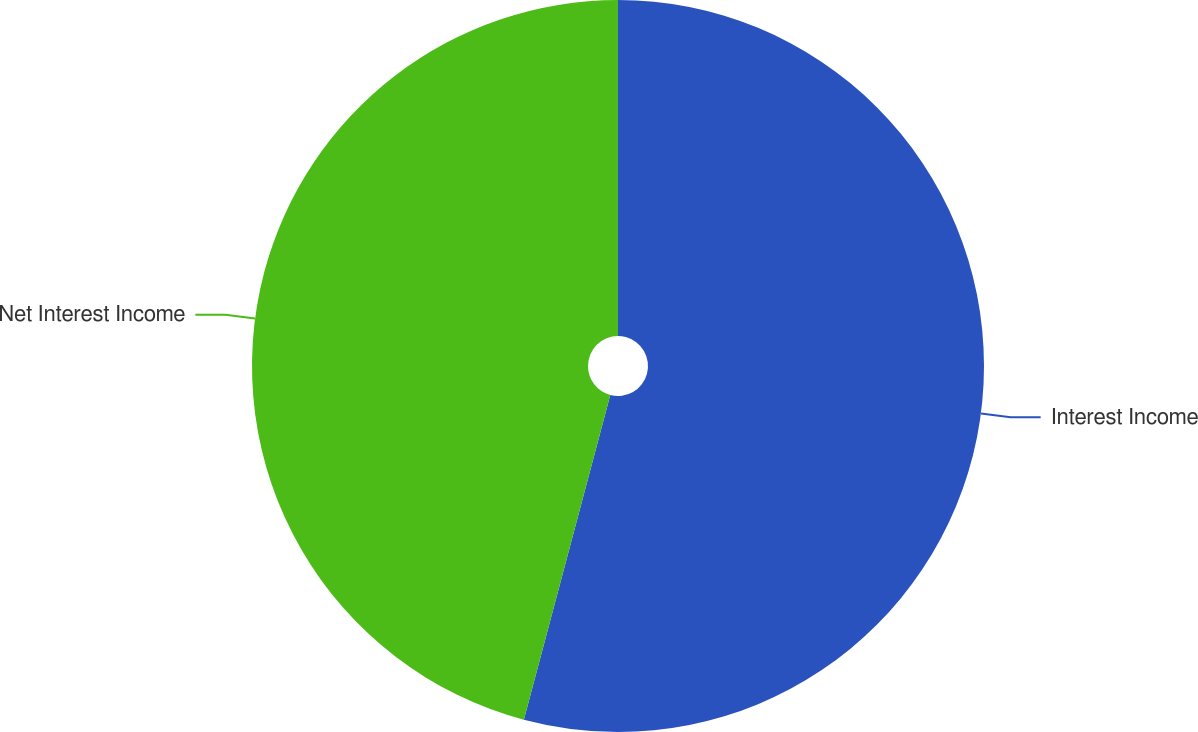Convert chart to OTSL. <chart><loc_0><loc_0><loc_500><loc_500><pie_chart><fcel>Interest Income<fcel>Net Interest Income<nl><fcel>54.14%<fcel>45.86%<nl></chart> 